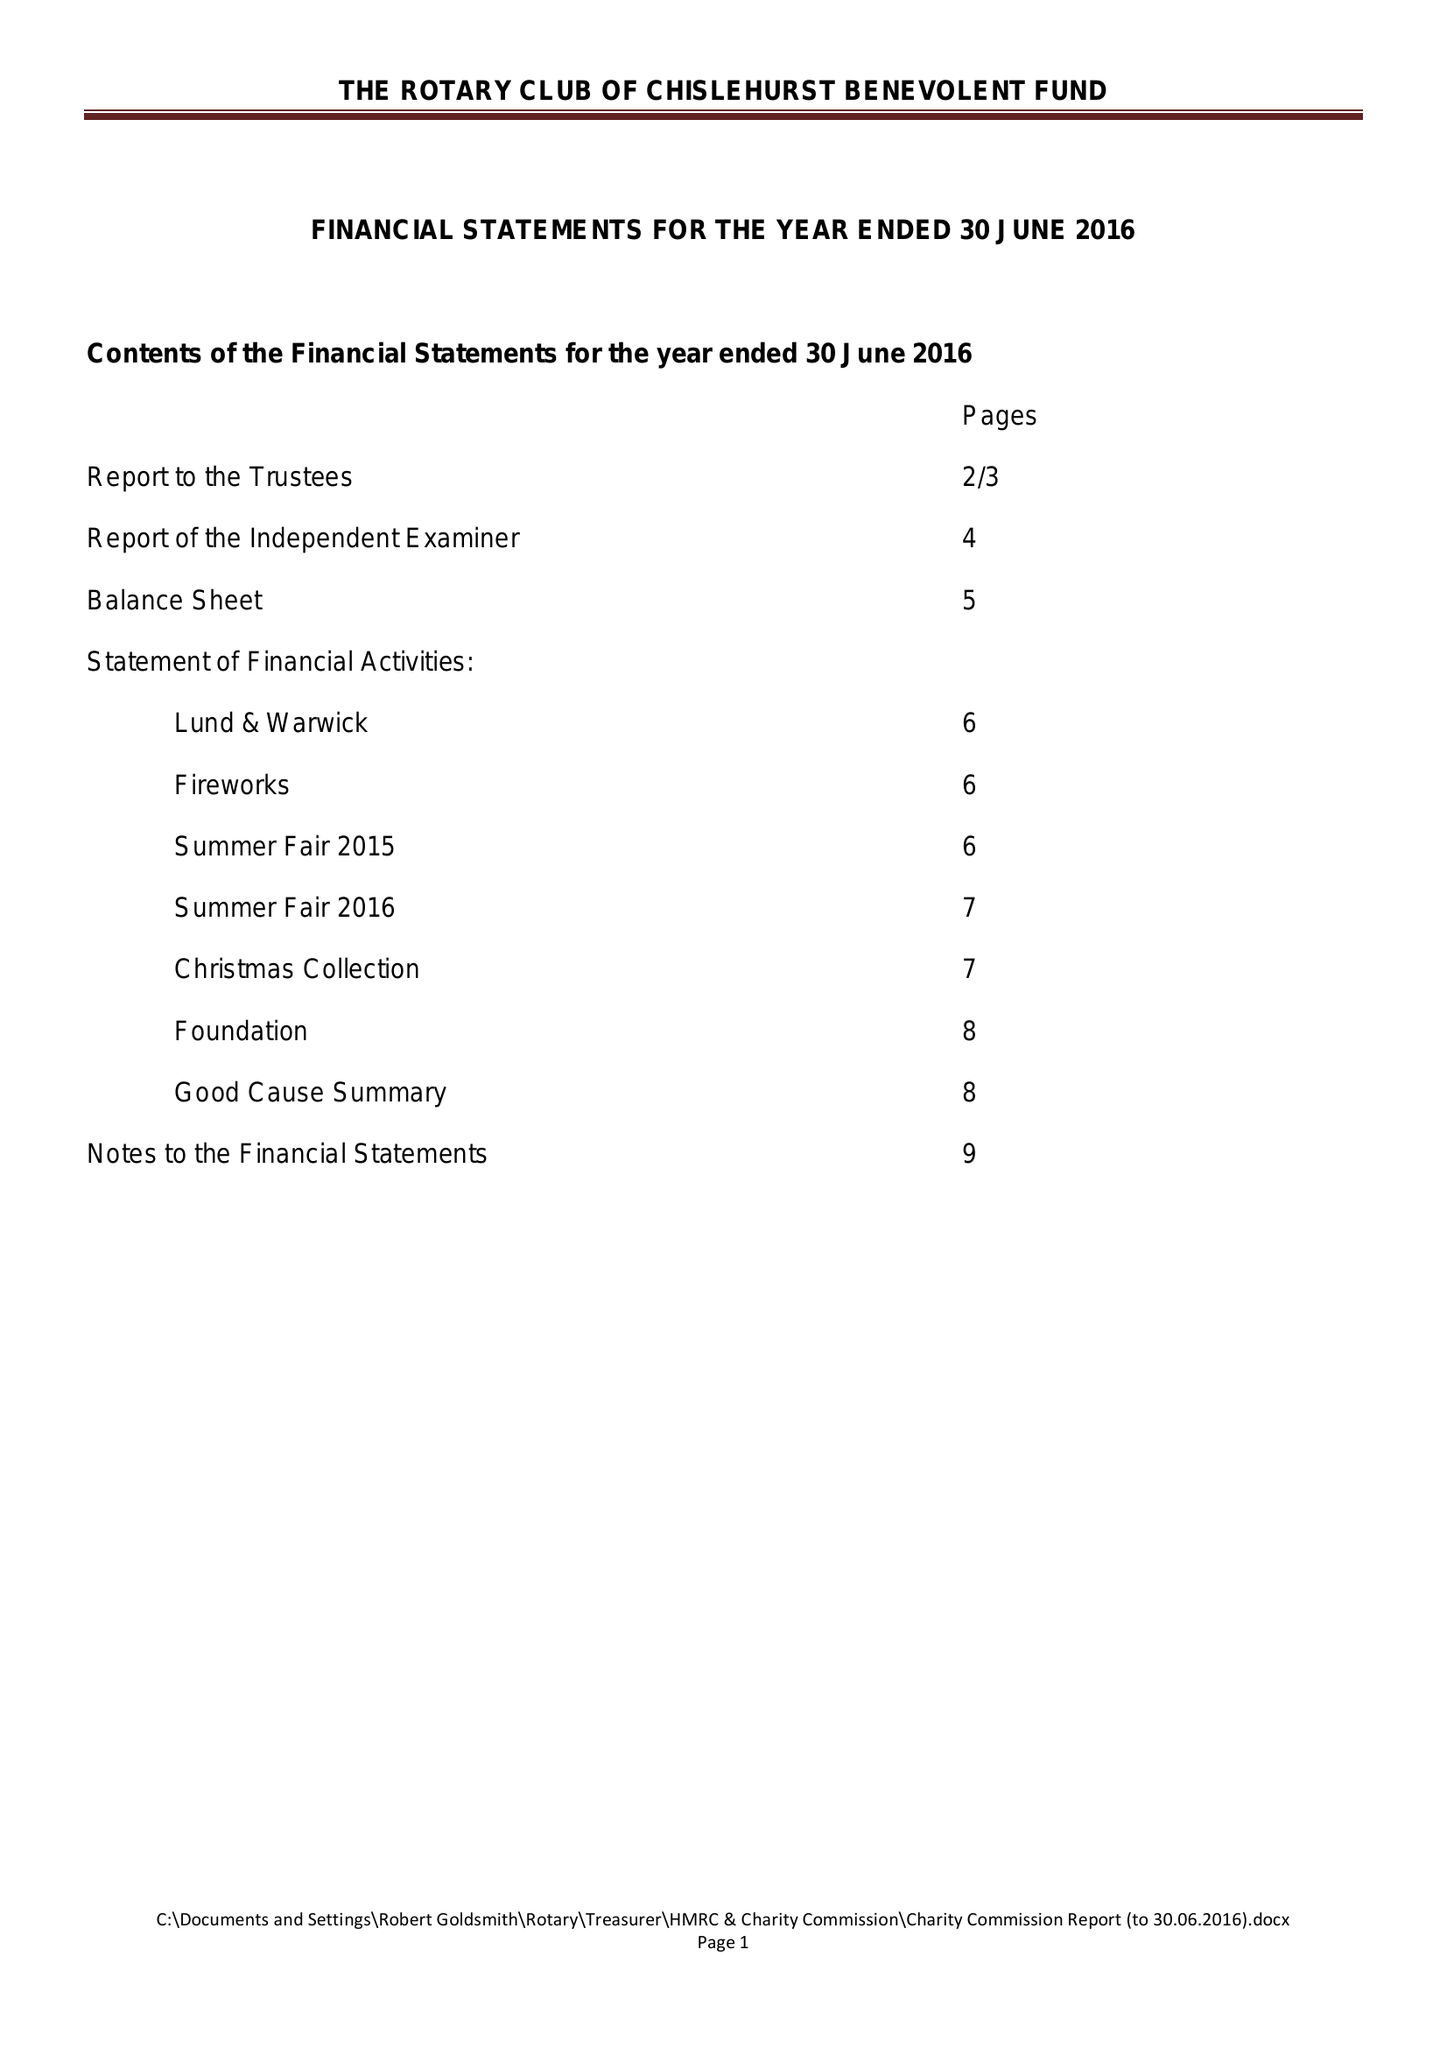What is the value for the charity_number?
Answer the question using a single word or phrase. 257747 